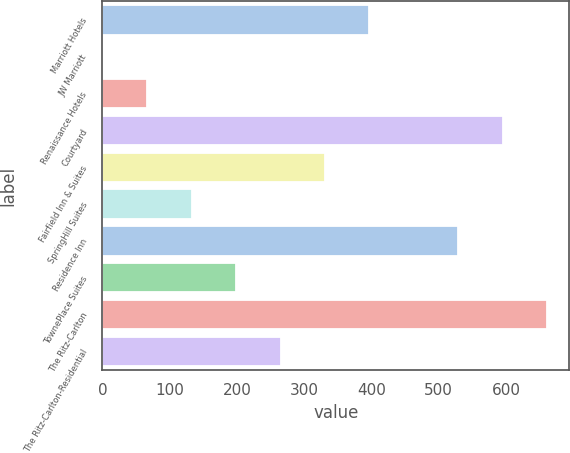<chart> <loc_0><loc_0><loc_500><loc_500><bar_chart><fcel>Marriott Hotels<fcel>JW Marriott<fcel>Renaissance Hotels<fcel>Courtyard<fcel>Fairfield Inn & Suites<fcel>SpringHill Suites<fcel>Residence Inn<fcel>TownePlace Suites<fcel>The Ritz-Carlton<fcel>The Ritz-Carlton-Residential<nl><fcel>397<fcel>1<fcel>67<fcel>595<fcel>331<fcel>133<fcel>529<fcel>199<fcel>661<fcel>265<nl></chart> 